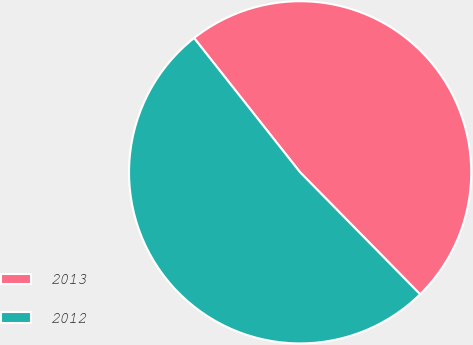Convert chart. <chart><loc_0><loc_0><loc_500><loc_500><pie_chart><fcel>2013<fcel>2012<nl><fcel>48.27%<fcel>51.73%<nl></chart> 